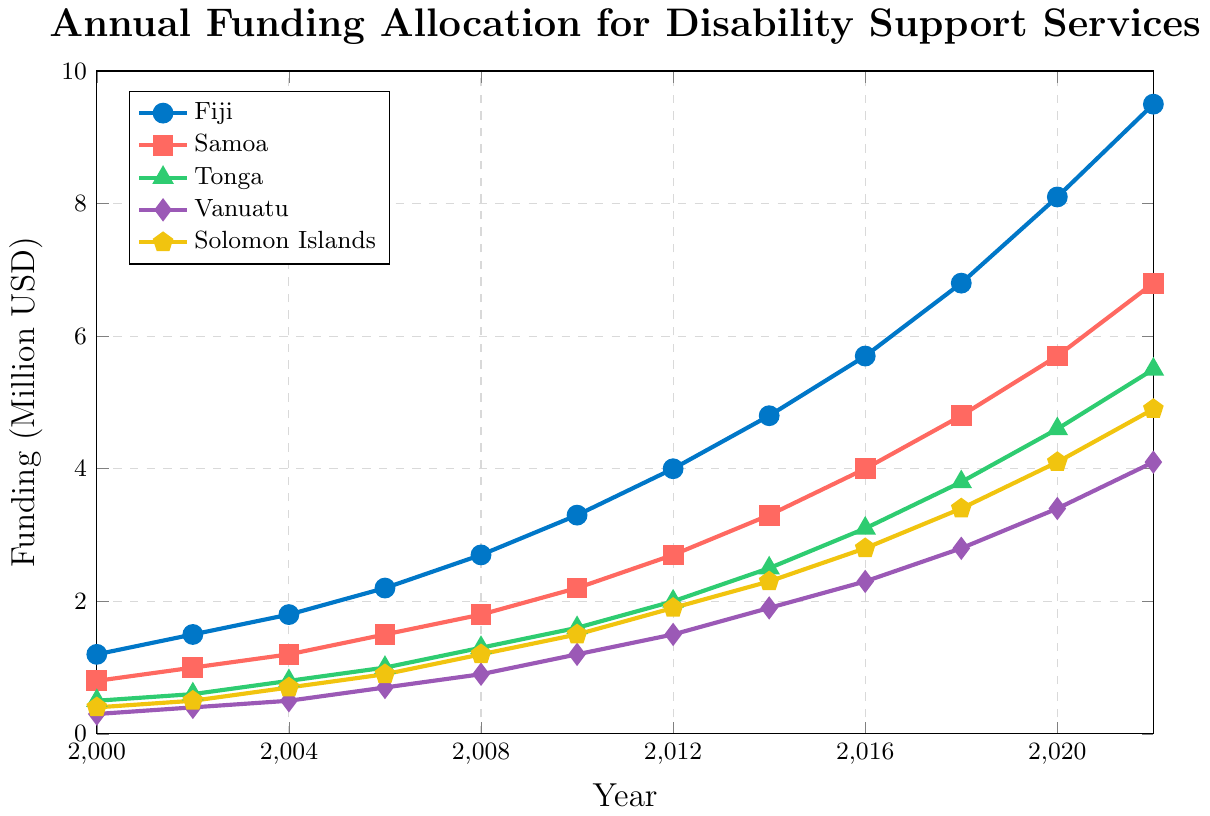Which country had the highest funding allocation in 2022? The data shows a line chart with different countries' funding allocations for each year. To determine which country had the highest funding allocation in 2022, examine the end points of the line plots for each country. Fiji's funding is 9.5 million USD, Samoa's is 6.8 million USD, Tonga's is 5.5 million USD, Vanuatu's is 4.1 million USD, and Solomon Islands' is 4.9 million USD. Thus, Fiji had the highest funding allocation in 2022.
Answer: Fiji By how much did Fiji's funding allocation increase from 2000 to 2022? Observe Fiji's funding allocation values in the years 2000 and 2022 from the chart. In 2000, it's 1.2 million USD, and in 2022, it's 9.5 million USD. Subtract the 2000 value from the 2022 value: 9.5 - 1.2 = 8.3 million USD.
Answer: 8.3 million USD Which two countries had the closest funding allocation in 2020, and what were their respective allocations? Look at the values for each country in 2020. Fiji has 8.1 million USD, Samoa has 5.7 million USD, Tonga has 4.6 million USD, Vanuatu has 3.4 million USD, and Solomon Islands has 4.1 million USD. Compare these values to find the two closest. The closest values are Tonga with 4.6 million USD and Solomon Islands with 4.1 million USD.
Answer: Tonga and Solomon Islands, 4.6 and 4.1 million USD Between which consecutive years did Vanuatu's funding experience the greatest increase, and what was the amount of the increase? Find the differences between the funding allocations for Vanuatu for each pair of consecutive years: (2002-2000), (2004-2002), (2006-2004), (2008-2006), (2010-2008), (2012-2010), (2014-2012), (2016-2014), (2018-2016), (2020-2018), and (2022-2020). Calculate these differences: 0.1, 0.1, 0.2, 0.2, 0.3, 0.3, 0.4, 0.4, 0.5, 0.6, and 0.7 million USD. The greatest increase happened between 2020 and 2022, and it's 0.7 million USD.
Answer: 2020-2022, 0.7 million USD What was the average funding allocation for Tonga from 2010 to 2022? Note the funding allocations for Tonga in each given year from 2010 to 2022: 1.6, 2.0, 2.5, 3.1, 3.8, 4.6, and 5.5 million USD. Sum these values: 1.6 + 2.0 + 2.5 + 3.1 + 3.8 + 4.6 + 5.5 = 23.1. Then divide by the number of data points, which is 7: 23.1 / 7 ≈ 3.3 million USD.
Answer: 3.3 million USD Which country shows the most consistent increase in funding allocation over the years? To determine consistency, observe the smoothness of the slope for each country's line on the chart. Fiji, Samoa, Tonga, Vanuatu, and Solomon Islands all show generally increasing trends, but Fiji has a steady, relatively smooth upward trend without large fluctuations, indicating the most consistent increase.
Answer: Fiji How does the funding allocation for the Solomon Islands in 2018 compare to that in 2014? Look at the chart for Solomon Islands in 2014 and 2018. In 2014, the allocation is 2.3 million USD, and in 2018, it's 3.4 million USD. The difference is 3.4 - 2.3 = 1.1 million USD, showing an increase.
Answer: Increased by 1.1 million USD What is the total funding allocation across all five countries in 2006? Sum the funding allocations for all five countries in 2006 from the chart: Fiji (2.2) + Samoa (1.5) + Tonga (1.0) + Vanuatu (0.7) + Solomon Islands (0.9). The total is 2.2 + 1.5 + 1.0 + 0.7 + 0.9 = 6.3 million USD.
Answer: 6.3 million USD In which year did Samoa's funding allocation surpass 3 million USD, and what was the exact value that year? Observe the line for Samoa and find the year it crosses the 3 million USD mark. In 2014, Samoa's allocation is 3.3 million USD, and this is the first time it surpasses 3 million USD.
Answer: 2014, 3.3 million USD Calculate the rate of increase in funding for Tonga between 2010 and 2022. Identify Tonga's funding in 2010 and 2022, which are 1.6 and 5.5 million USD respectively. Subtract the 2010 value from the 2022 value: 5.5 - 1.6 = 3.9 million USD. To find the rate of increase per year, divide by the number of years (2022 - 2010 = 12 years): 3.9 / 12 ≈ 0.325 million USD per year.
Answer: 0.325 million USD per year 